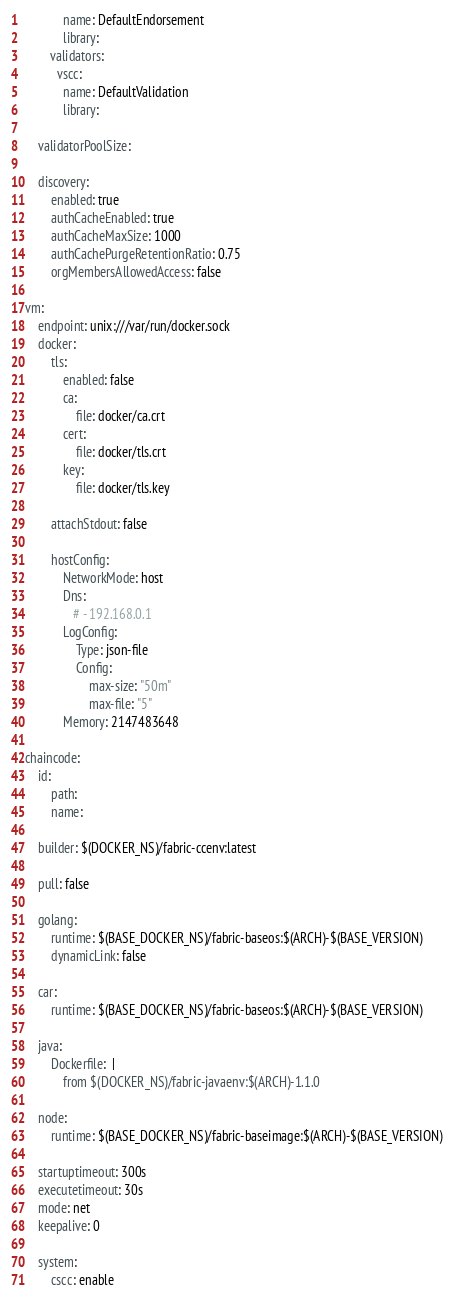Convert code to text. <code><loc_0><loc_0><loc_500><loc_500><_YAML_>            name: DefaultEndorsement
            library:
        validators:
          vscc:
            name: DefaultValidation
            library:

    validatorPoolSize:

    discovery:
        enabled: true
        authCacheEnabled: true
        authCacheMaxSize: 1000
        authCachePurgeRetentionRatio: 0.75
        orgMembersAllowedAccess: false

vm:
    endpoint: unix:///var/run/docker.sock
    docker:
        tls:
            enabled: false
            ca:
                file: docker/ca.crt
            cert:
                file: docker/tls.crt
            key:
                file: docker/tls.key

        attachStdout: false

        hostConfig:
            NetworkMode: host
            Dns:
               # - 192.168.0.1
            LogConfig:
                Type: json-file
                Config:
                    max-size: "50m"
                    max-file: "5"
            Memory: 2147483648

chaincode:
    id:
        path:
        name:

    builder: $(DOCKER_NS)/fabric-ccenv:latest

    pull: false

    golang:
        runtime: $(BASE_DOCKER_NS)/fabric-baseos:$(ARCH)-$(BASE_VERSION)
        dynamicLink: false

    car:
        runtime: $(BASE_DOCKER_NS)/fabric-baseos:$(ARCH)-$(BASE_VERSION)

    java:
        Dockerfile:  |
            from $(DOCKER_NS)/fabric-javaenv:$(ARCH)-1.1.0

    node:
        runtime: $(BASE_DOCKER_NS)/fabric-baseimage:$(ARCH)-$(BASE_VERSION)

    startuptimeout: 300s
    executetimeout: 30s
    mode: net 
    keepalive: 0

    system:
        cscc: enable</code> 